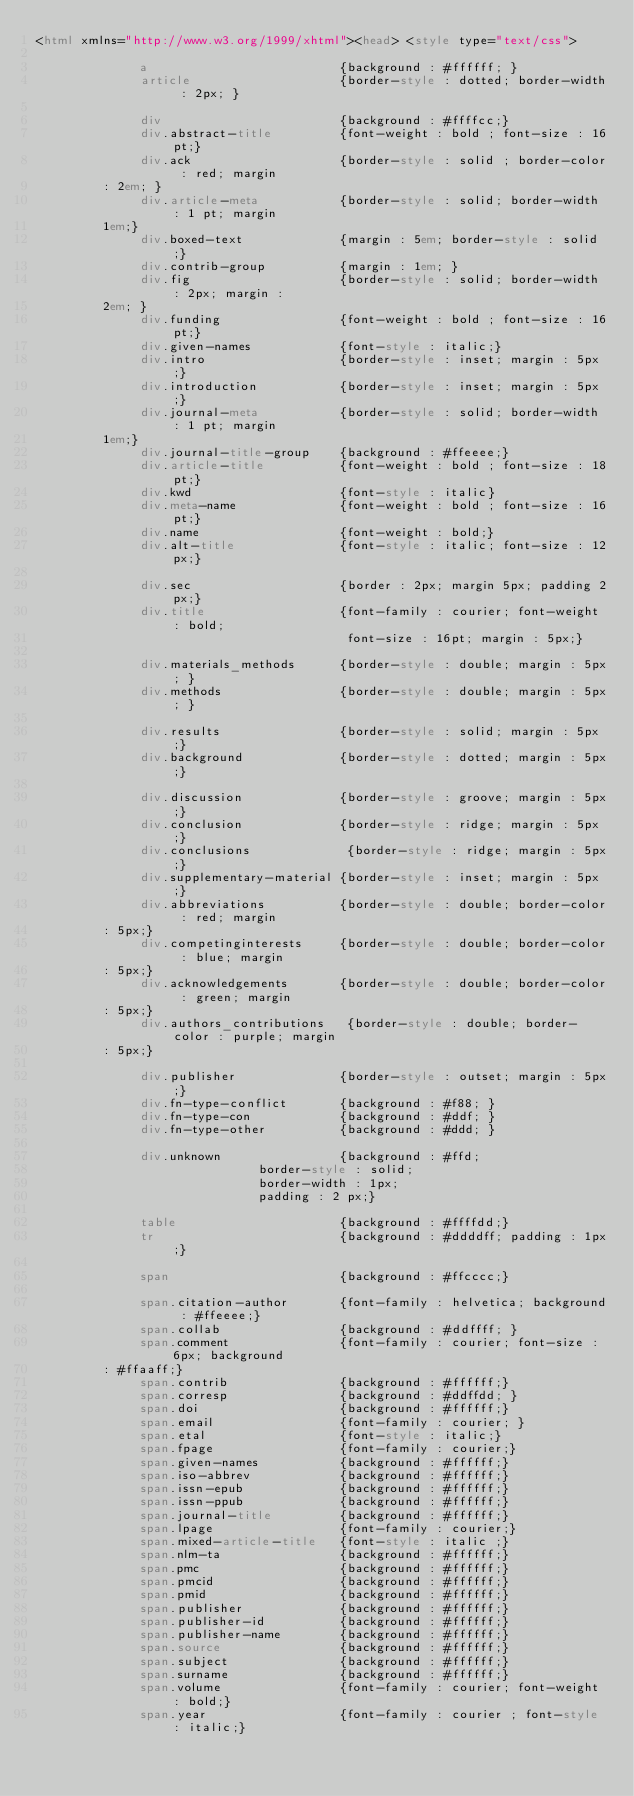<code> <loc_0><loc_0><loc_500><loc_500><_HTML_><html xmlns="http://www.w3.org/1999/xhtml"><head> <style type="text/css">
         	     		 
         	    a                          {background : #ffffff; }
         	    article                    {border-style : dotted; border-width : 2px; }
         		 	
         		 	div                        {background : #ffffcc;}
         		 	div.abstract-title         {font-weight : bold ; font-size : 16pt;}
         		 	div.ack                    {border-style : solid ; border-color : red; margin
         : 2em; }
         		 	div.article-meta           {border-style : solid; border-width : 1 pt; margin
         1em;}
         		 	div.boxed-text             {margin : 5em; border-style : solid;}
         		 	div.contrib-group          {margin : 1em; }
         		 	div.fig                    {border-style : solid; border-width : 2px; margin :
         2em; }
         		 	div.funding                {font-weight : bold ; font-size : 16pt;}
         		 	div.given-names            {font-style : italic;}
         		 	div.intro                  {border-style : inset; margin : 5px;}
         		 	div.introduction           {border-style : inset; margin : 5px;}
         		 	div.journal-meta           {border-style : solid; border-width : 1 pt; margin
         1em;}
         		 	div.journal-title-group    {background : #ffeeee;}
         		 	div.article-title          {font-weight : bold ; font-size : 18pt;}
         		 	div.kwd                    {font-style : italic}
         		 	div.meta-name              {font-weight : bold ; font-size : 16pt;}
         		 	div.name                   {font-weight : bold;}
         		 	div.alt-title              {font-style : italic; font-size : 12px;}
         		 	
         		 	div.sec                    {border : 2px; margin 5px; padding 2px;}
         		 	div.title                  {font-family : courier; font-weight : bold;
         		 	                            font-size : 16pt; margin : 5px;}
         		 	
         		 	div.materials_methods      {border-style : double; margin : 5px; }
         		 	div.methods                {border-style : double; margin : 5px; }
         		 	
         		 	div.results                {border-style : solid; margin : 5px;}
         		 	div.background             {border-style : dotted; margin : 5px;}
         		 	
         		 	div.discussion             {border-style : groove; margin : 5px;}
         		 	div.conclusion             {border-style : ridge; margin : 5px;}
         		 	div.conclusions             {border-style : ridge; margin : 5px;}
         		 	div.supplementary-material {border-style : inset; margin : 5px;}
         		 	div.abbreviations          {border-style : double; border-color : red; margin
         : 5px;}
         		 	div.competinginterests     {border-style : double; border-color : blue; margin
         : 5px;}
         		 	div.acknowledgements       {border-style : double; border-color : green; margin
         : 5px;}
         		 	div.authors_contributions   {border-style : double; border-color : purple; margin
         : 5px;}
         		 	
         		 	div.publisher              {border-style : outset; margin : 5px;}
         		 	div.fn-type-conflict       {background : #f88; }
         		 	div.fn-type-con            {background : #ddf; }
         		 	div.fn-type-other          {background : #ddd; }
         		 	
         		 	div.unknown                {background : #ffd;
         									 	  border-style : solid;
         									 	  border-width : 1px;
         									 	  padding : 2 px;}
         		 	  
         	    table                      {background : #ffffdd;}
         		 	tr                         {background : #ddddff; padding : 1px;}
         		 	
         		 	span                       {background : #ffcccc;}
         		 	
         		 	span.citation-author       {font-family : helvetica; background : #ffeeee;}
         		 	span.collab                {background : #ddffff; }
         		 	span.comment               {font-family : courier; font-size : 6px; background
         : #ffaaff;}
         		 	span.contrib               {background : #ffffff;}
         		 	span.corresp               {background : #ddffdd; }
         		 	span.doi                   {background : #ffffff;}
         		 	span.email                 {font-family : courier; }
         		 	span.etal                  {font-style : italic;}
         		 	span.fpage                 {font-family : courier;}
         		 	span.given-names           {background : #ffffff;}
         		 	span.iso-abbrev            {background : #ffffff;}
         		 	span.issn-epub             {background : #ffffff;}
         		 	span.issn-ppub             {background : #ffffff;}
         		 	span.journal-title         {background : #ffffff;}
         		 	span.lpage                 {font-family : courier;}
         		 	span.mixed-article-title   {font-style : italic ;}
         		 	span.nlm-ta                {background : #ffffff;}
         		 	span.pmc                   {background : #ffffff;}
         		 	span.pmcid                 {background : #ffffff;}
         		 	span.pmid                  {background : #ffffff;}
         		 	span.publisher             {background : #ffffff;}
         		 	span.publisher-id          {background : #ffffff;}
         		 	span.publisher-name        {background : #ffffff;}
         		 	span.source                {background : #ffffff;}
         		 	span.subject               {background : #ffffff;}
         		 	span.surname               {background : #ffffff;}
         		 	span.volume                {font-family : courier; font-weight : bold;}
         		 	span.year                  {font-family : courier ; font-style : italic;}
         			</code> 